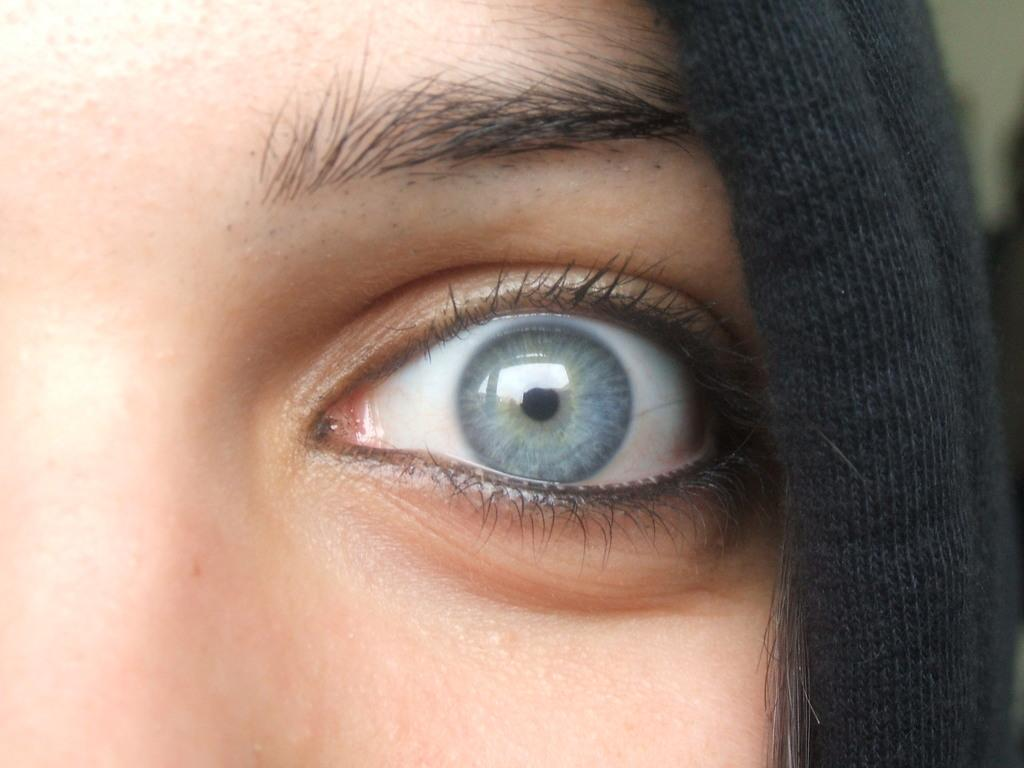What part of a person's face is the main subject of the image? There is an eye of a person in the image. What else can be seen on the right side of the image? There is an object on the right side of the image, which is black in color. Can you describe any other facial features visible in the image? There is an eyebrow visible in the image. How many chickens are present in the image? There are no chickens present in the image; it features an eye and an eyebrow of a person. What is the weight of the stew in the image? There is no stew present in the image, so its weight cannot be determined. 